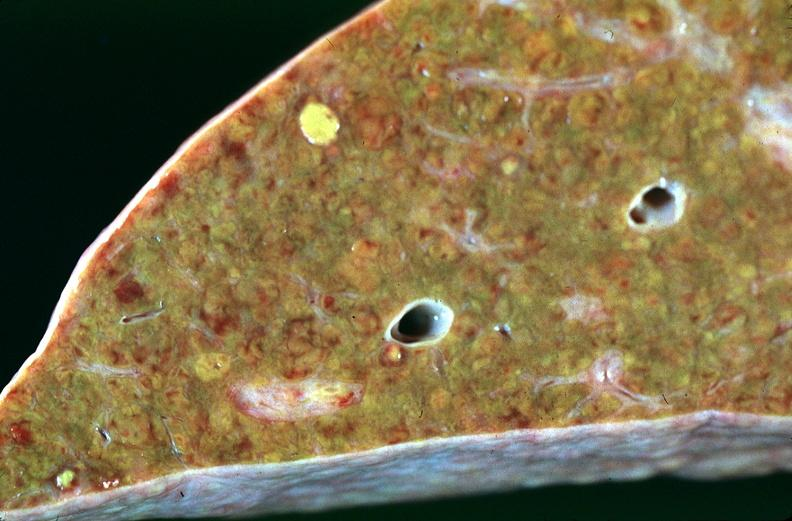does cortical nodule show liver, cirrhosis alpha-1 antitrypsin deficiency?
Answer the question using a single word or phrase. No 